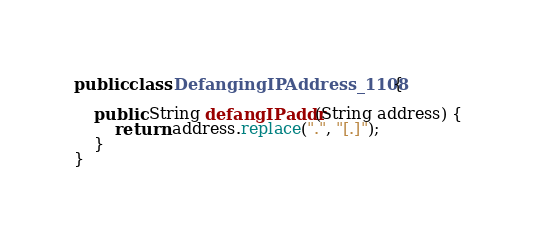Convert code to text. <code><loc_0><loc_0><loc_500><loc_500><_Java_>
public class DefangingIPAddress_1108 {

    public String defangIPaddr(String address) {
        return address.replace(".", "[.]");
    }
}
</code> 